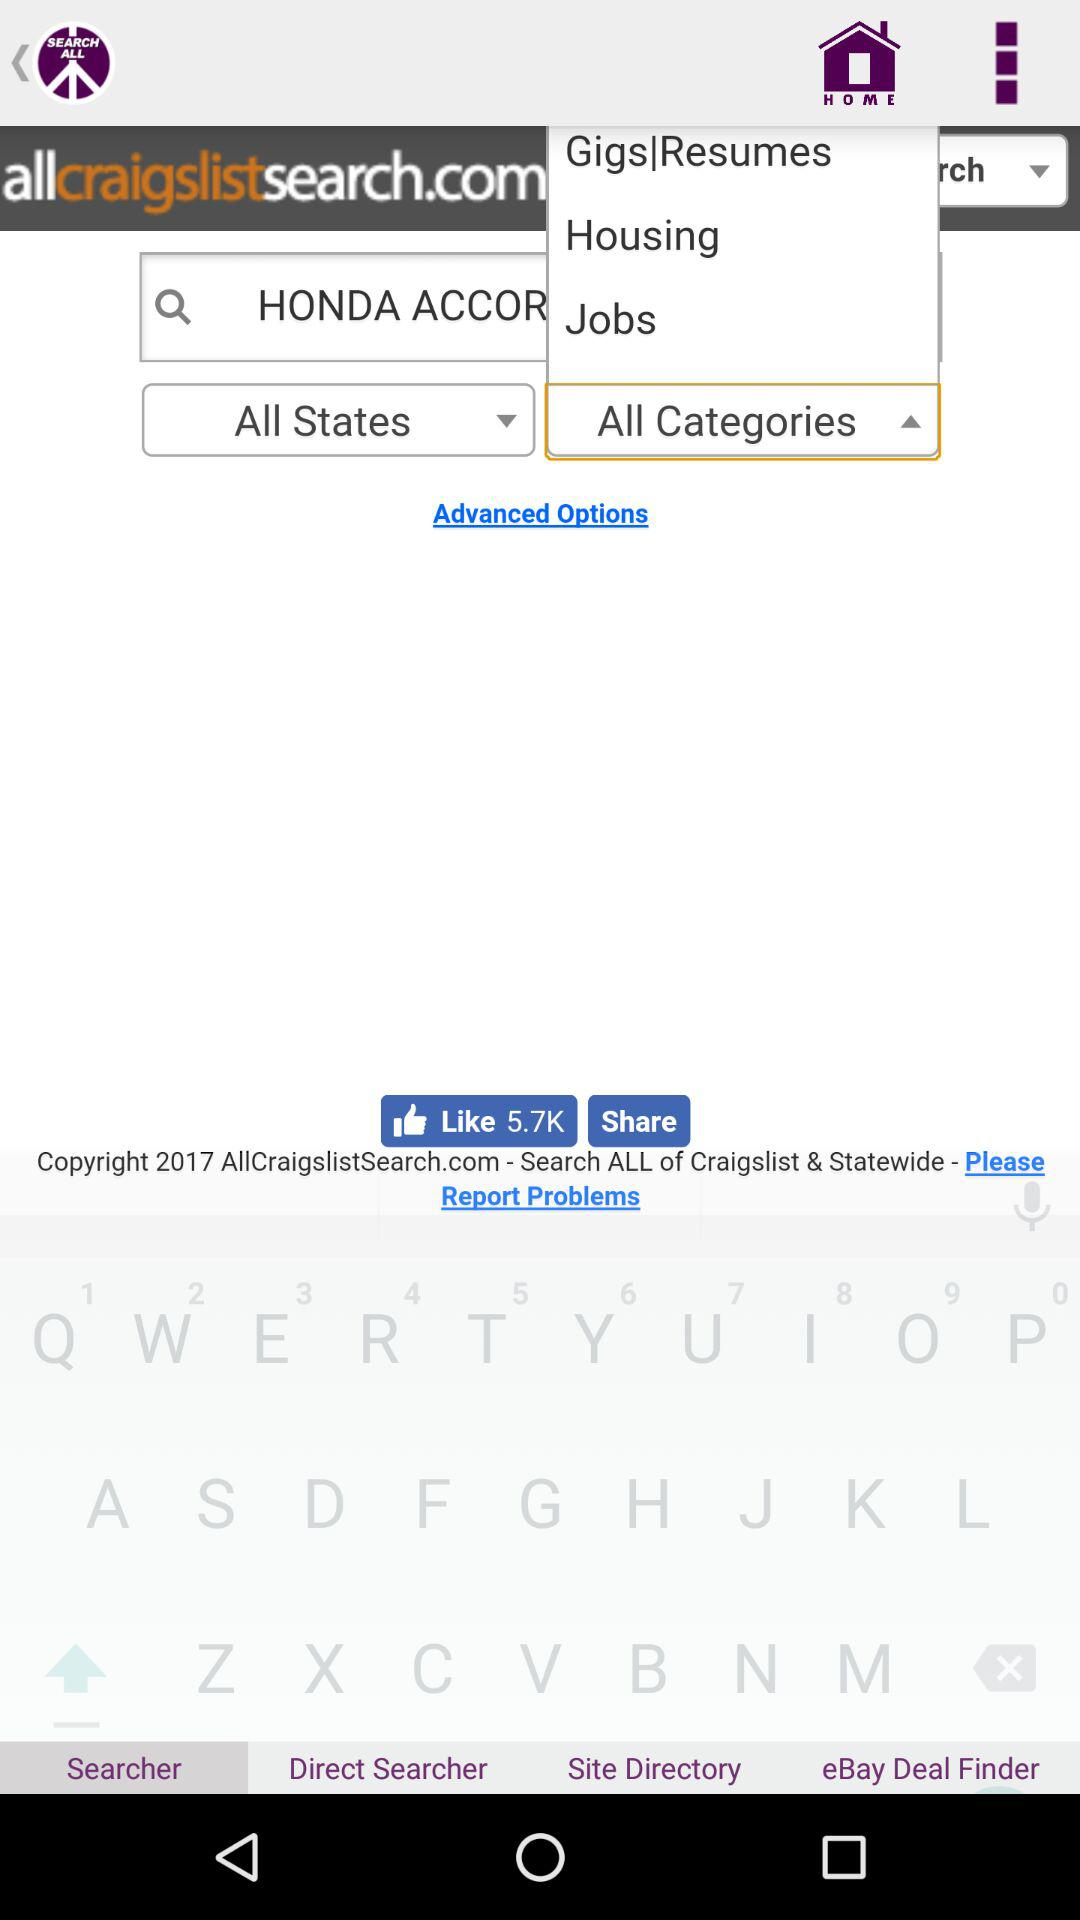With which applications can we share?
When the provided information is insufficient, respond with <no answer>. <no answer> 